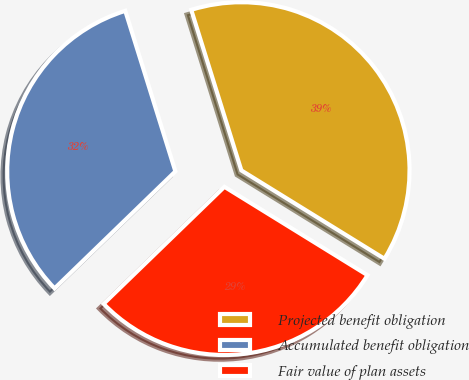Convert chart to OTSL. <chart><loc_0><loc_0><loc_500><loc_500><pie_chart><fcel>Projected benefit obligation<fcel>Accumulated benefit obligation<fcel>Fair value of plan assets<nl><fcel>38.62%<fcel>32.43%<fcel>28.95%<nl></chart> 